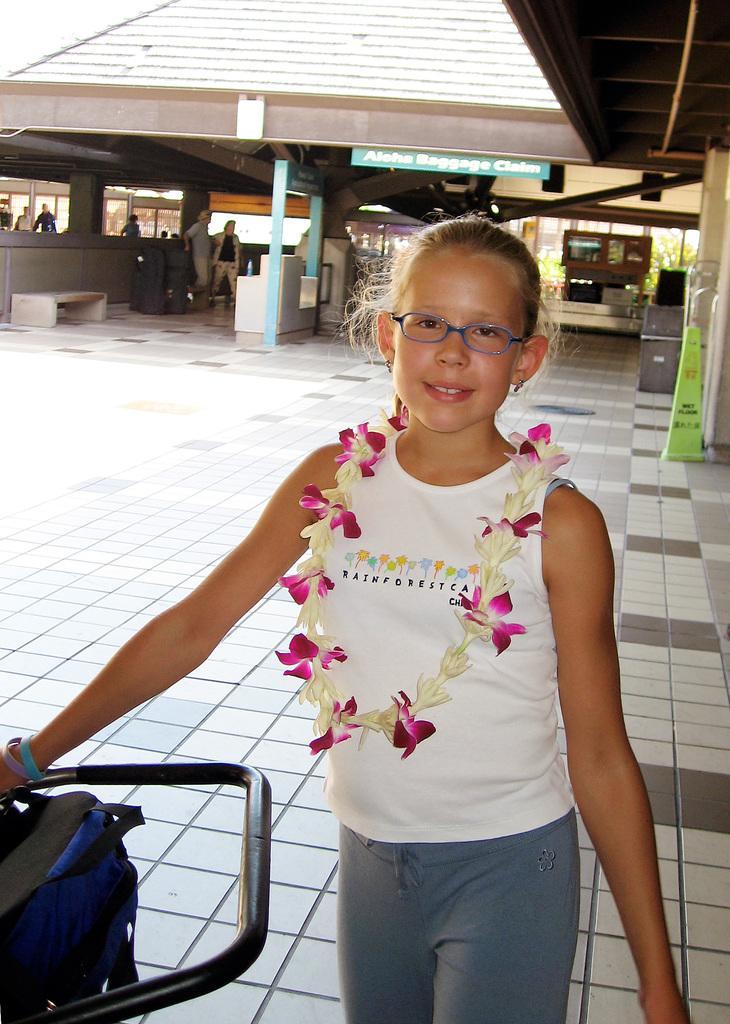Can you describe this image briefly? In this image I can see a girl is standing in the front. I can see she is wearing a white colour top, a specs, a grey pant and a garland of flowers. I can also see a blue colour bag on the bottom left side of the image. In the background I can see few boards, a seat, few people, few plants and few other things. I can also see something is written on the board. 